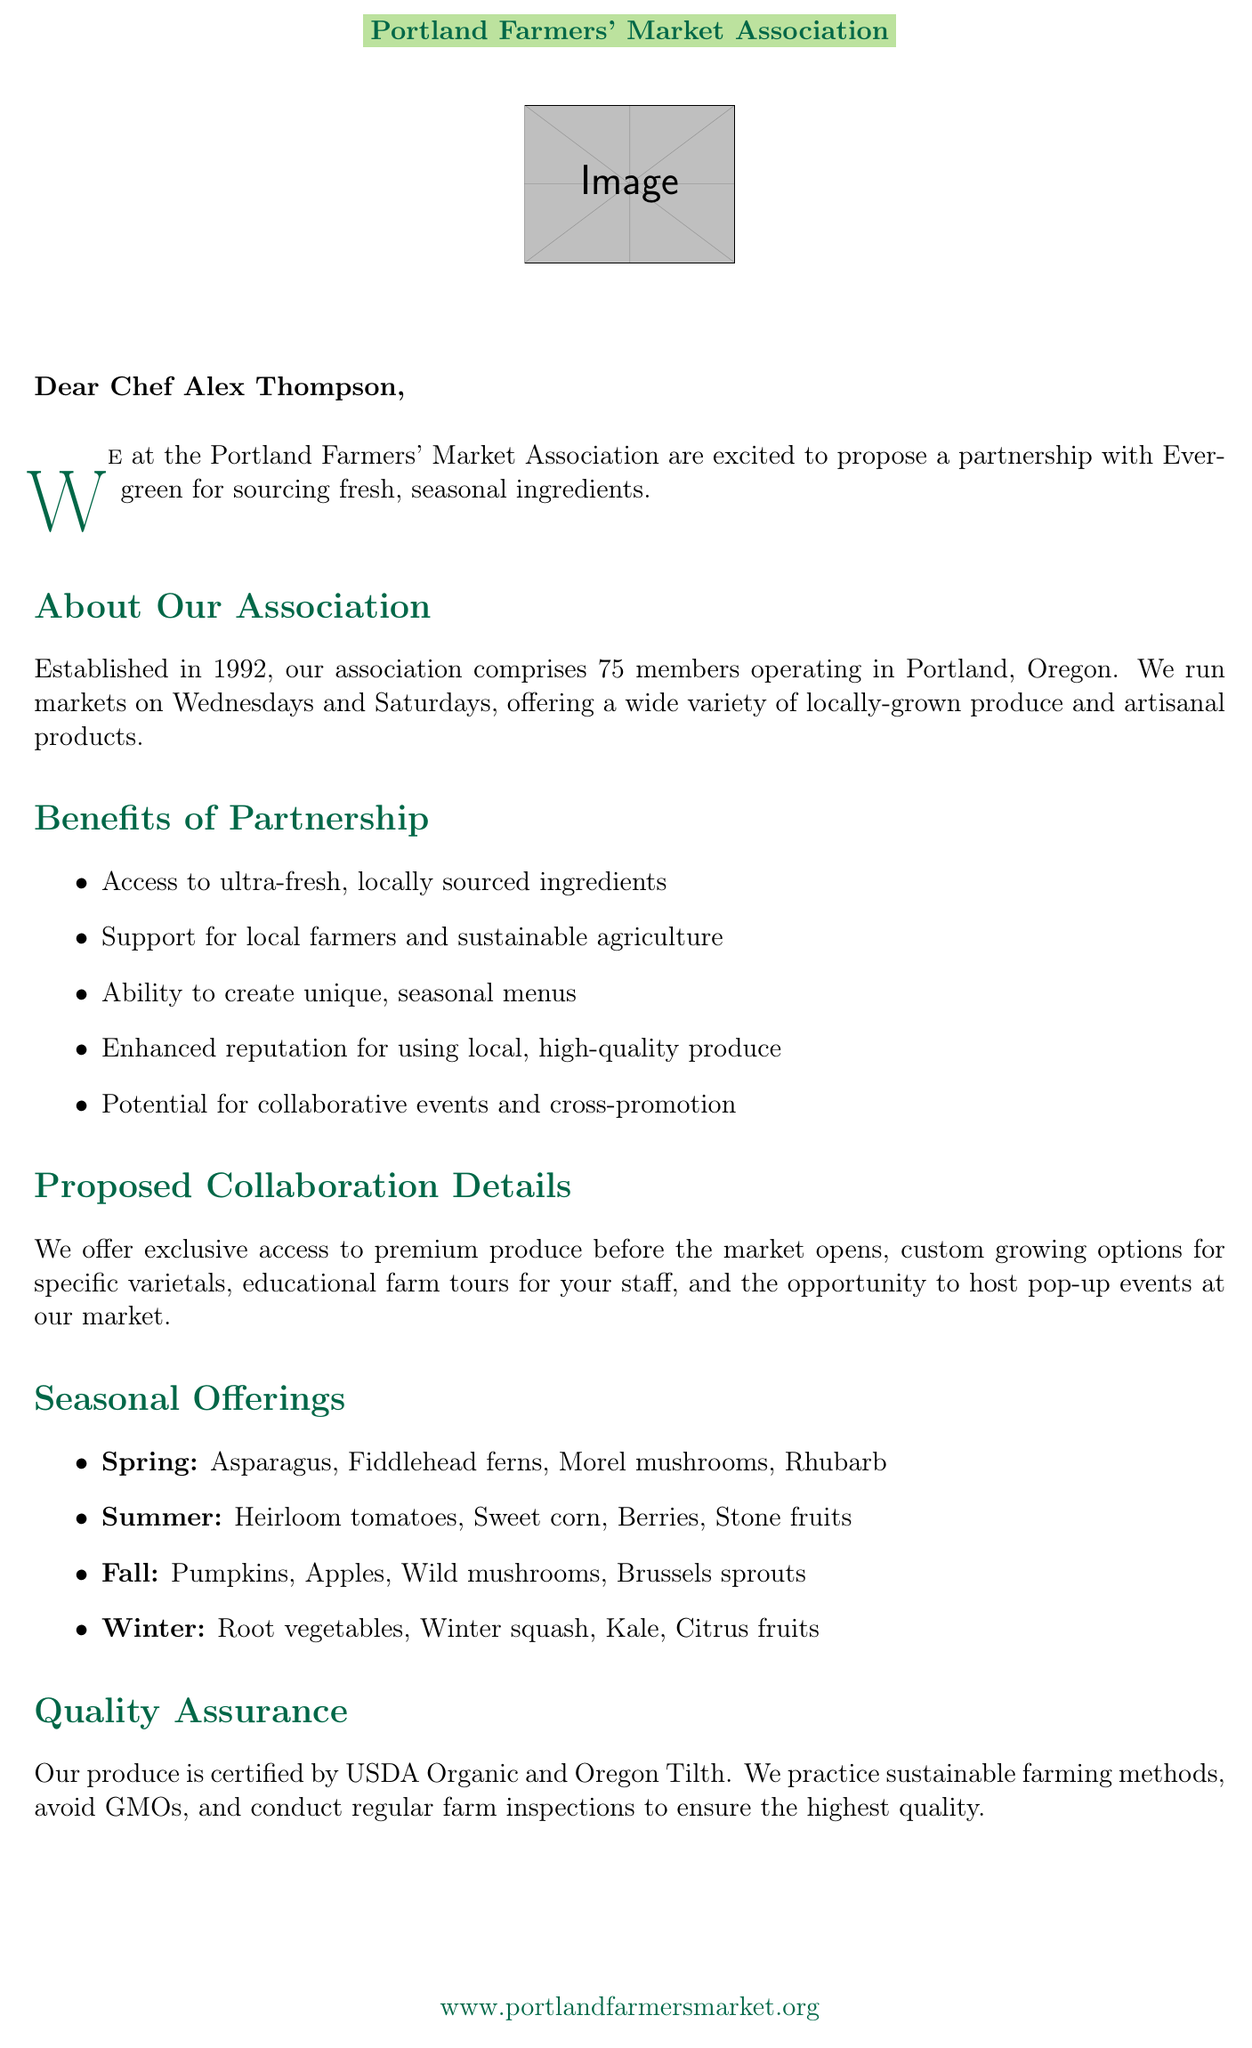What is the name of the farmers' market association? The document clearly states that it is the Portland Farmers' Market Association.
Answer: Portland Farmers' Market Association In which year was the farmers' market association established? The establishment year is mentioned in the document as 1992.
Answer: 1992 How many members does the farmers' market association have? The document indicates that the association comprises 75 members.
Answer: 75 What are the operating days of the farmers' market? The document lists Wednesday and Saturday as the market days.
Answer: Wednesday, Saturday What is one of the benefits of the partnership mentioned? The document highlights access to ultra-fresh, locally sourced ingredients as a benefit.
Answer: Access to ultra-fresh, locally sourced ingredients What is the proposed frequency of deliveries? The document specifies that deliveries will be twice-weekly.
Answer: Twice-weekly What type of restaurant is Evergreen? The document describes it as a high-end farm-to-table restaurant.
Answer: High-end farm-to-table restaurant What ingredient is listed for spring seasonal offerings? The document mentions asparagus as one of the spring seasonal offerings.
Answer: Asparagus What opportunity is offered for educational purposes? The document states that there will be educational farm tours for the kitchen staff.
Answer: Educational farm tours What does the quality assurance section mention about farming practices? The document mentions sustainable farming methods in relation to quality assurance.
Answer: Sustainable farming methods 